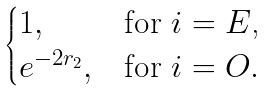<formula> <loc_0><loc_0><loc_500><loc_500>\begin{cases} 1 , & \text {for $i = E$,} \\ e ^ { - 2 r _ { 2 } } , & \text {for $i = O$} . \end{cases}</formula> 